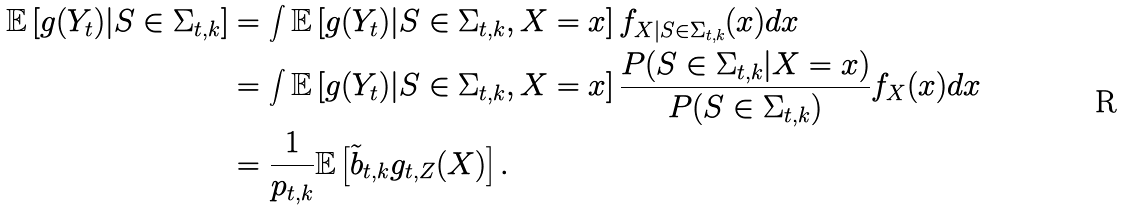Convert formula to latex. <formula><loc_0><loc_0><loc_500><loc_500>\mathbb { E } \left [ g ( Y _ { t } ) | S \in \Sigma _ { t , k } \right ] & = \int \mathbb { E } \left [ g ( Y _ { t } ) | S \in \Sigma _ { t , k } , X = x \right ] f _ { X | S \in \Sigma _ { t , k } } ( x ) d x \\ & = \int \mathbb { E } \left [ g ( Y _ { t } ) | S \in \Sigma _ { t , k } , X = x \right ] \frac { P ( S \in \Sigma _ { t , k } | X = x ) } { P ( S \in \Sigma _ { t , k } ) } f _ { X } ( x ) d x \\ & = \frac { 1 } { p _ { t , k } } \mathbb { E } \left [ \tilde { b } _ { t , k } g _ { t , Z } ( X ) \right ] .</formula> 